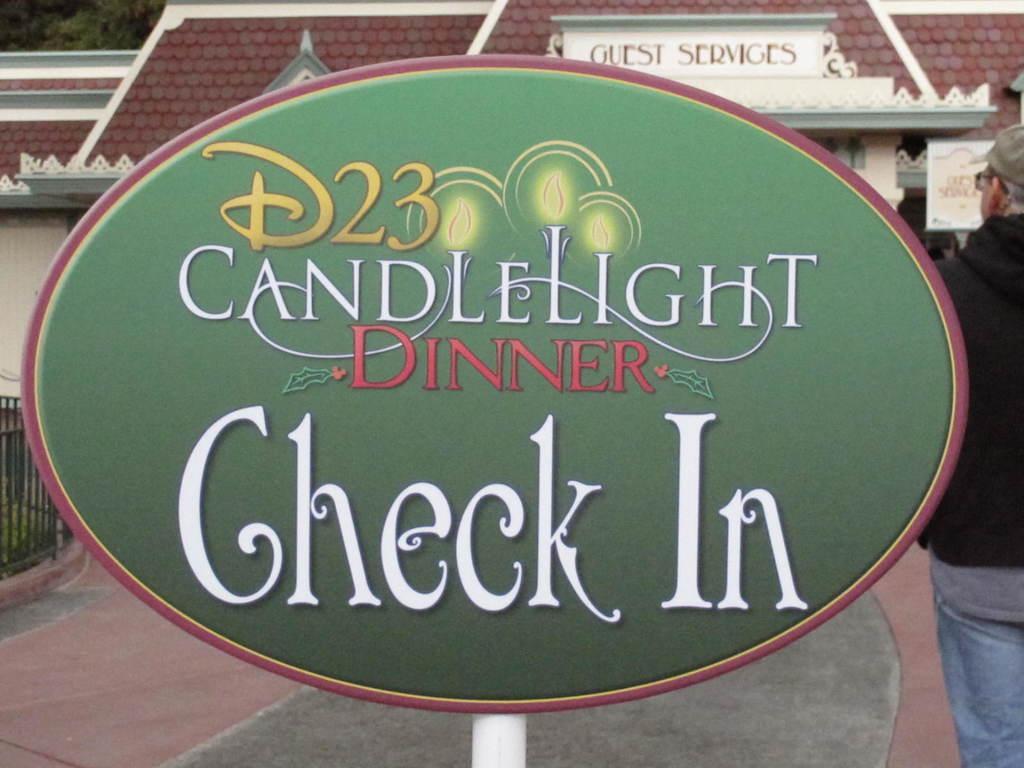How would you summarize this image in a sentence or two? In the center of the image we can see one banner. On the banner, we can see some text. In the background, we can see trees, one building, banners, fence, one person standing and a few other objects. 